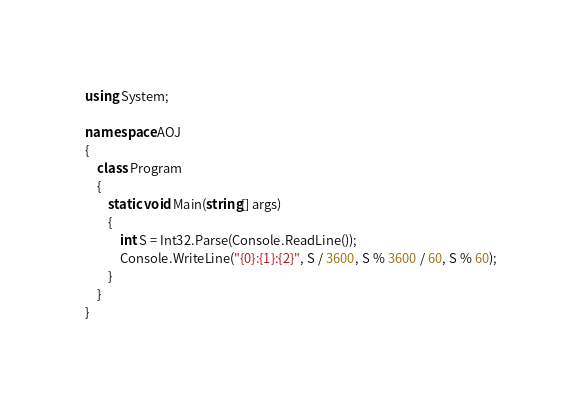<code> <loc_0><loc_0><loc_500><loc_500><_C#_>using System;

namespace AOJ
{
	class Program
	{
		static void Main(string[] args)
		{
			int S = Int32.Parse(Console.ReadLine());
			Console.WriteLine("{0}:{1}:{2}", S / 3600, S % 3600 / 60, S % 60);
		}
	}
}</code> 